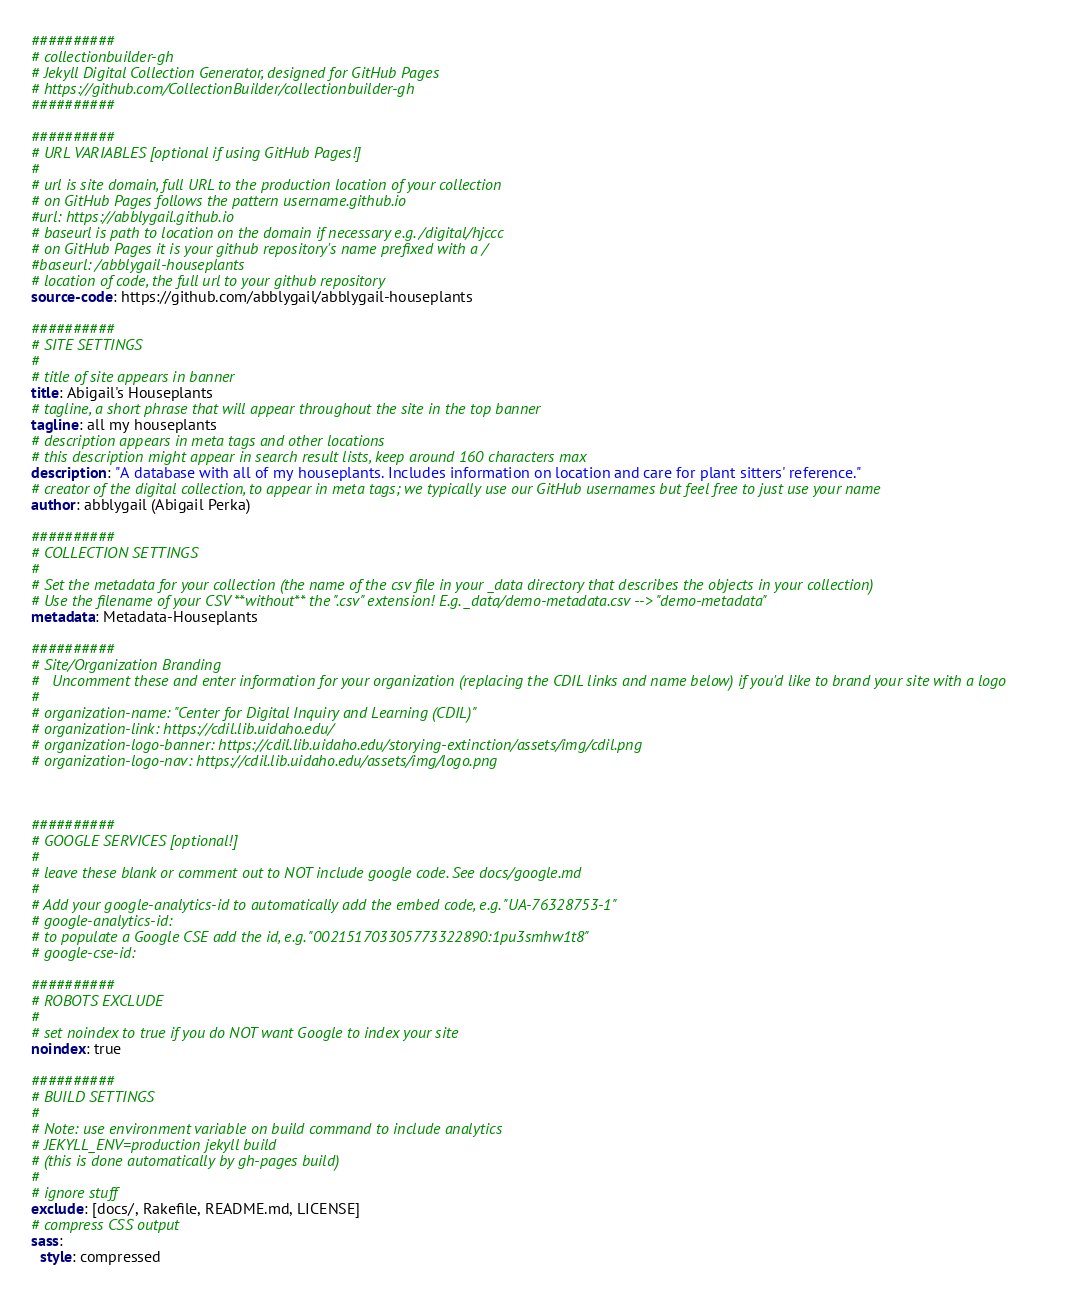<code> <loc_0><loc_0><loc_500><loc_500><_YAML_>##########
# collectionbuilder-gh
# Jekyll Digital Collection Generator, designed for GitHub Pages
# https://github.com/CollectionBuilder/collectionbuilder-gh
##########

##########
# URL VARIABLES [optional if using GitHub Pages!]
#
# url is site domain, full URL to the production location of your collection
# on GitHub Pages follows the pattern username.github.io
#url: https://abblygail.github.io 
# baseurl is path to location on the domain if necessary e.g. /digital/hjccc
# on GitHub Pages it is your github repository's name prefixed with a /
#baseurl: /abblygail-houseplants 
# location of code, the full url to your github repository
source-code: https://github.com/abblygail/abblygail-houseplants

##########
# SITE SETTINGS
#
# title of site appears in banner
title: Abigail's Houseplants 
# tagline, a short phrase that will appear throughout the site in the top banner
tagline: all my houseplants
# description appears in meta tags and other locations
# this description might appear in search result lists, keep around 160 characters max
description: "A database with all of my houseplants. Includes information on location and care for plant sitters' reference."
# creator of the digital collection, to appear in meta tags; we typically use our GitHub usernames but feel free to just use your name
author: abblygail (Abigail Perka)

##########
# COLLECTION SETTINGS
#
# Set the metadata for your collection (the name of the csv file in your _data directory that describes the objects in your collection) 
# Use the filename of your CSV **without** the ".csv" extension! E.g. _data/demo-metadata.csv --> "demo-metadata"
metadata: Metadata-Houseplants 

##########
# Site/Organization Branding 
#   Uncomment these and enter information for your organization (replacing the CDIL links and name below) if you'd like to brand your site with a logo
#
# organization-name: "Center for Digital Inquiry and Learning (CDIL)"
# organization-link: https://cdil.lib.uidaho.edu/
# organization-logo-banner: https://cdil.lib.uidaho.edu/storying-extinction/assets/img/cdil.png
# organization-logo-nav: https://cdil.lib.uidaho.edu/assets/img/logo.png



##########
# GOOGLE SERVICES [optional!]
#
# leave these blank or comment out to NOT include google code. See docs/google.md
#
# Add your google-analytics-id to automatically add the embed code, e.g. "UA-76328753-1"
# google-analytics-id:
# to populate a Google CSE add the id, e.g. "002151703305773322890:1pu3smhw1t8"
# google-cse-id: 

##########
# ROBOTS EXCLUDE
#
# set noindex to true if you do NOT want Google to index your site
noindex: true 

##########
# BUILD SETTINGS 
#
# Note: use environment variable on build command to include analytics
# JEKYLL_ENV=production jekyll build
# (this is done automatically by gh-pages build)
#
# ignore stuff
exclude: [docs/, Rakefile, README.md, LICENSE]
# compress CSS output
sass:
  style: compressed
</code> 